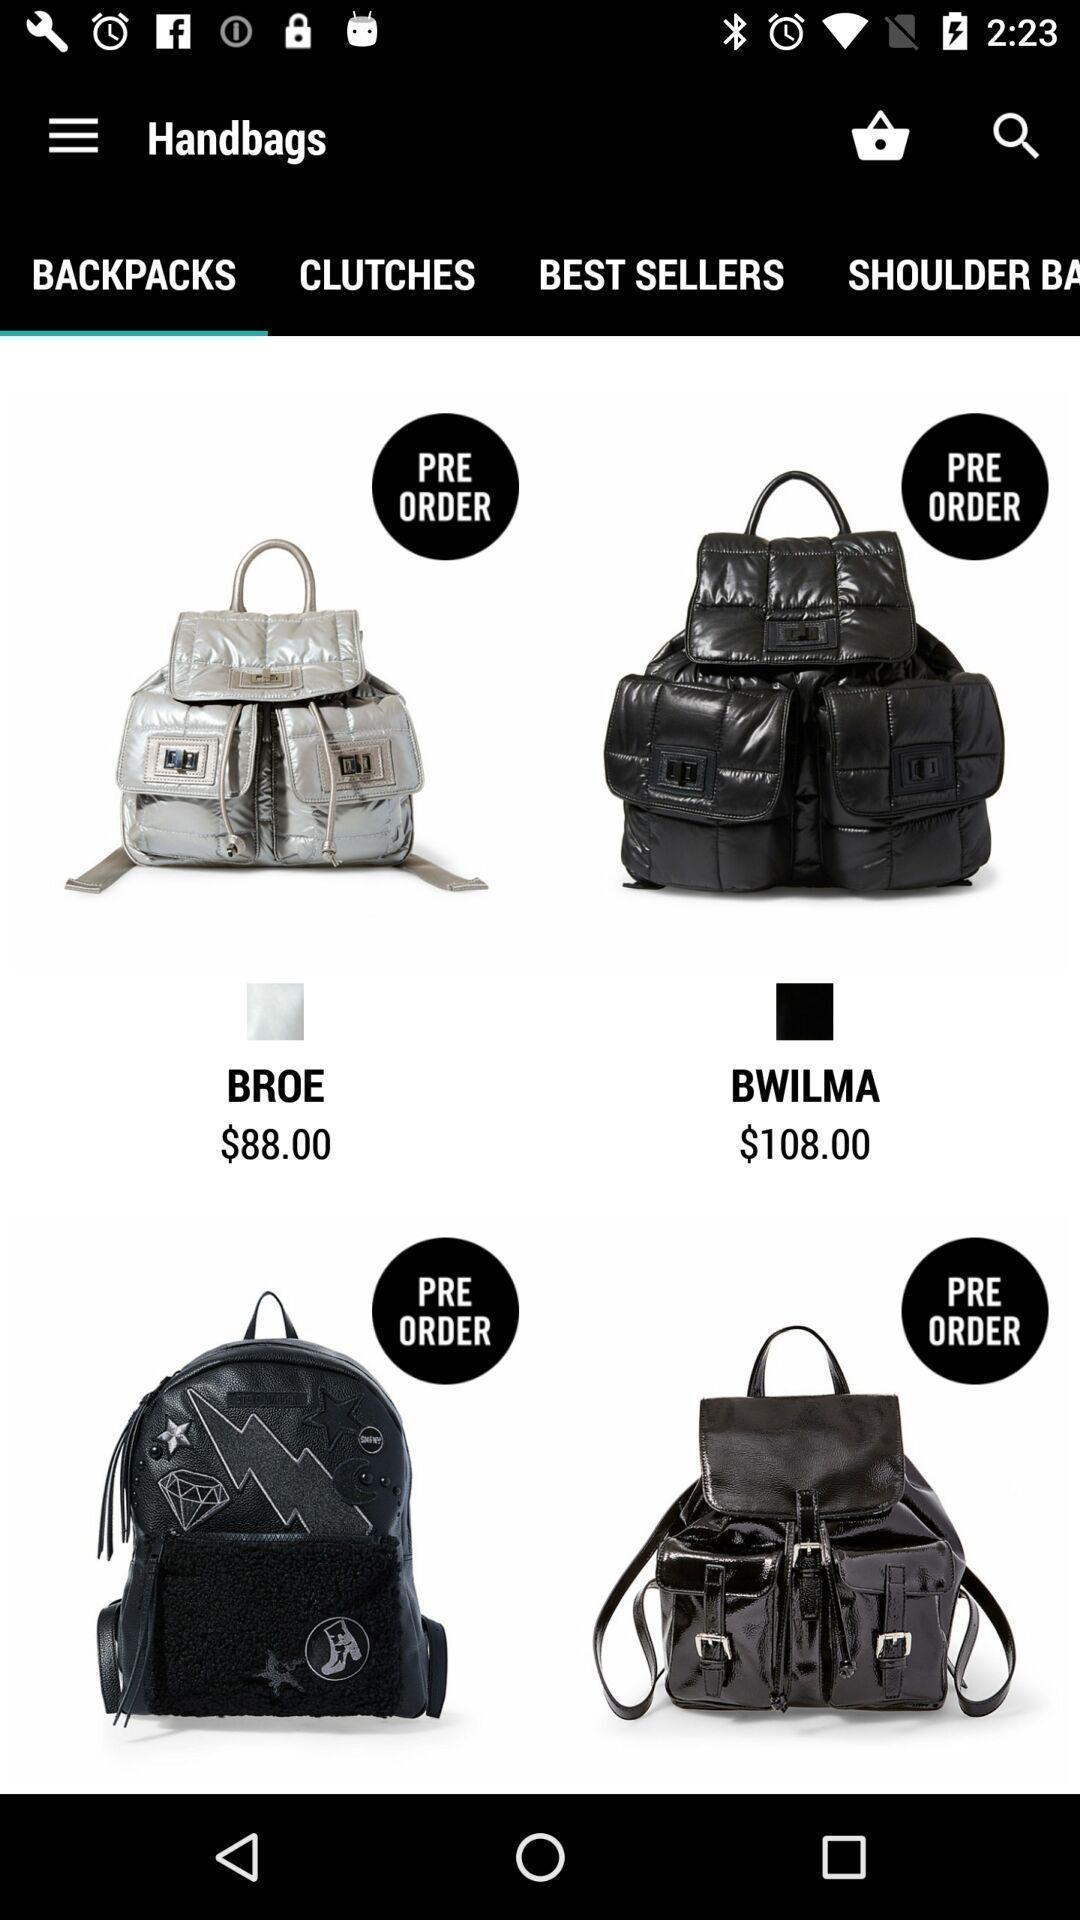What is the overall content of this screenshot? Various back pack images displayed in a online shopping app. 